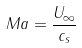<formula> <loc_0><loc_0><loc_500><loc_500>M a = \frac { U _ { \infty } } { c _ { s } }</formula> 